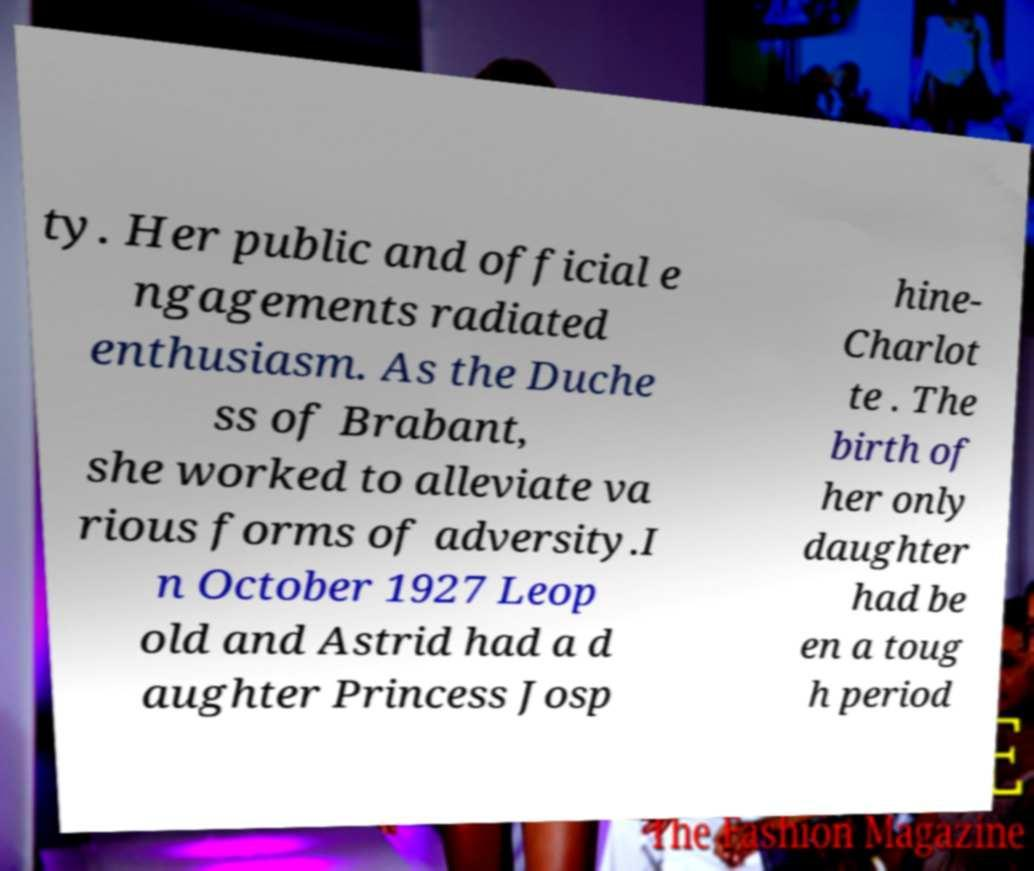Can you read and provide the text displayed in the image?This photo seems to have some interesting text. Can you extract and type it out for me? ty. Her public and official e ngagements radiated enthusiasm. As the Duche ss of Brabant, she worked to alleviate va rious forms of adversity.I n October 1927 Leop old and Astrid had a d aughter Princess Josp hine- Charlot te . The birth of her only daughter had be en a toug h period 